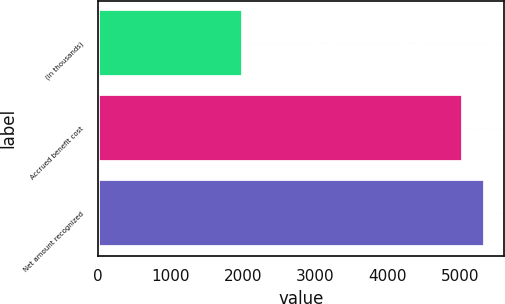<chart> <loc_0><loc_0><loc_500><loc_500><bar_chart><fcel>(in thousands)<fcel>Accrued benefit cost<fcel>Net amount recognized<nl><fcel>2003<fcel>5037<fcel>5340.4<nl></chart> 